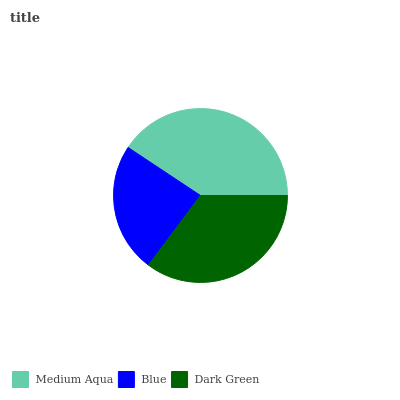Is Blue the minimum?
Answer yes or no. Yes. Is Medium Aqua the maximum?
Answer yes or no. Yes. Is Dark Green the minimum?
Answer yes or no. No. Is Dark Green the maximum?
Answer yes or no. No. Is Dark Green greater than Blue?
Answer yes or no. Yes. Is Blue less than Dark Green?
Answer yes or no. Yes. Is Blue greater than Dark Green?
Answer yes or no. No. Is Dark Green less than Blue?
Answer yes or no. No. Is Dark Green the high median?
Answer yes or no. Yes. Is Dark Green the low median?
Answer yes or no. Yes. Is Blue the high median?
Answer yes or no. No. Is Medium Aqua the low median?
Answer yes or no. No. 